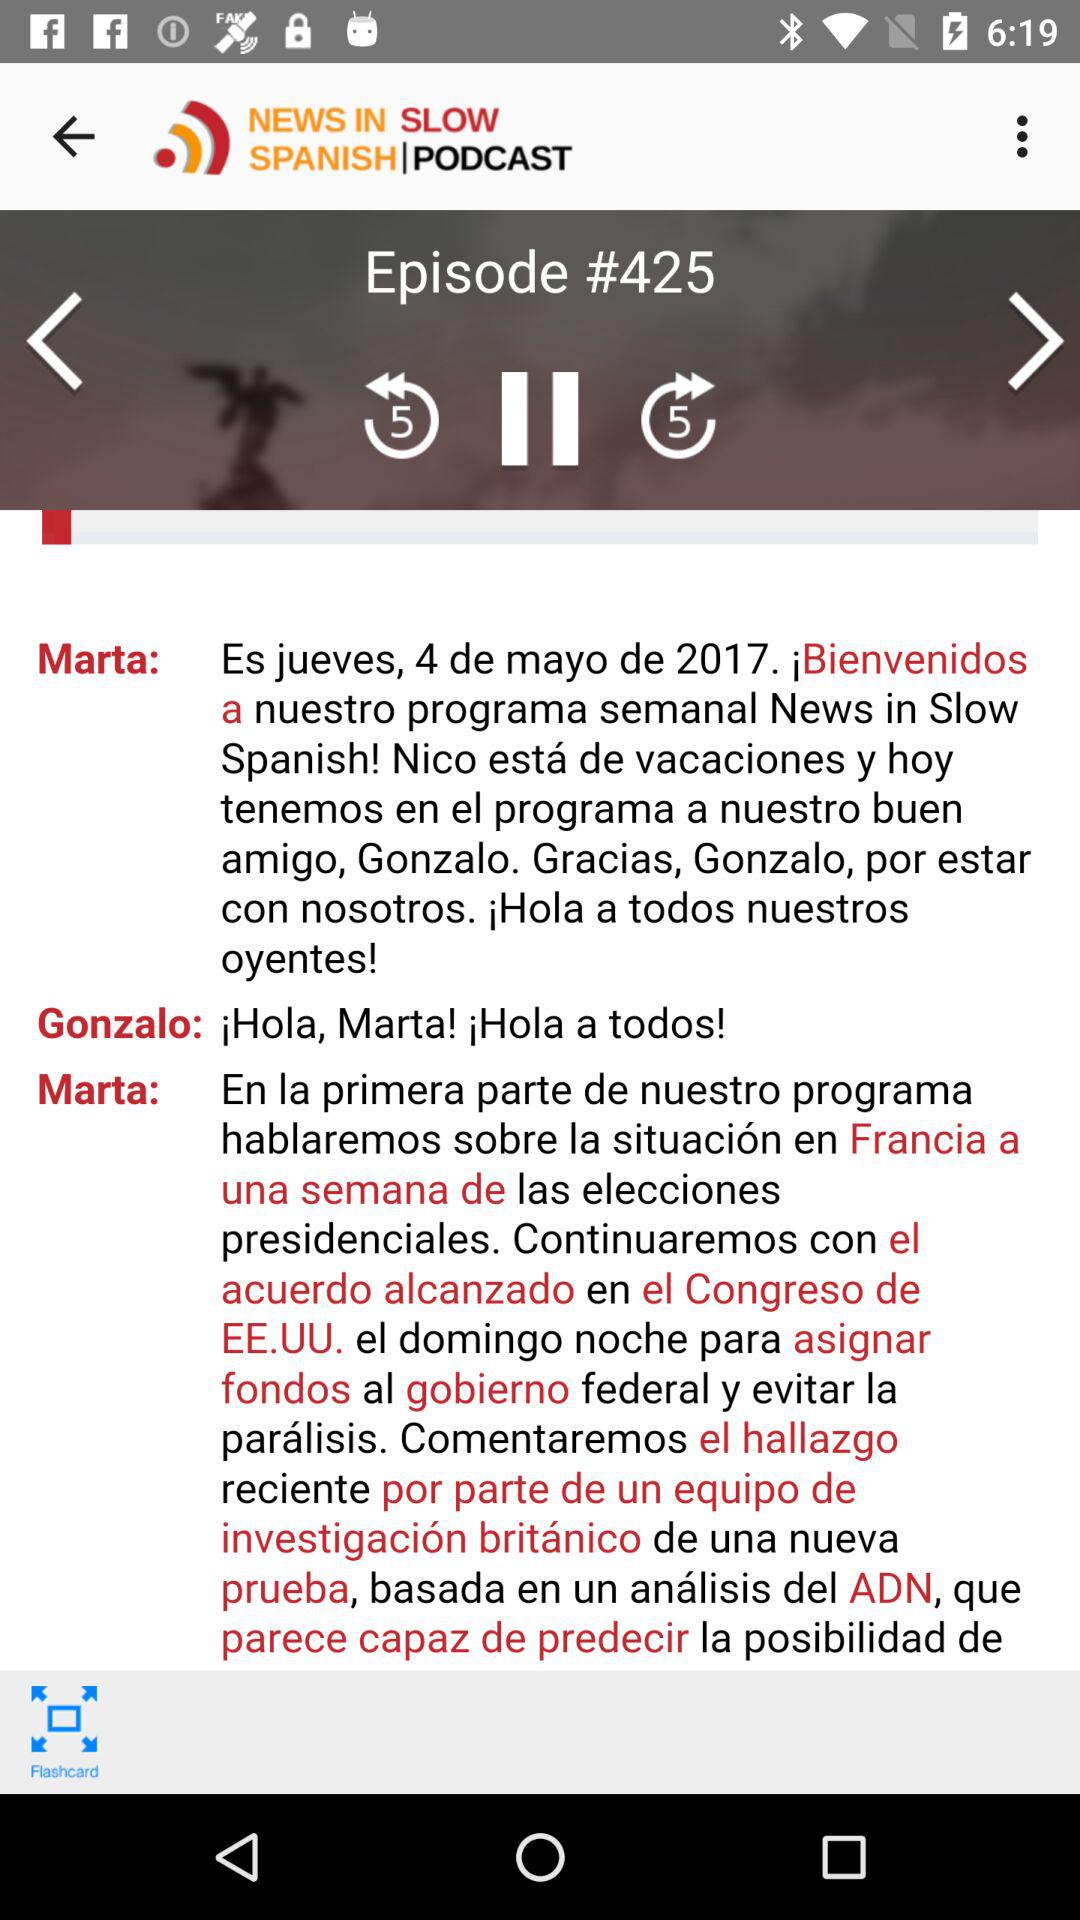When was the podcast uploaded?
When the provided information is insufficient, respond with <no answer>. <no answer> 